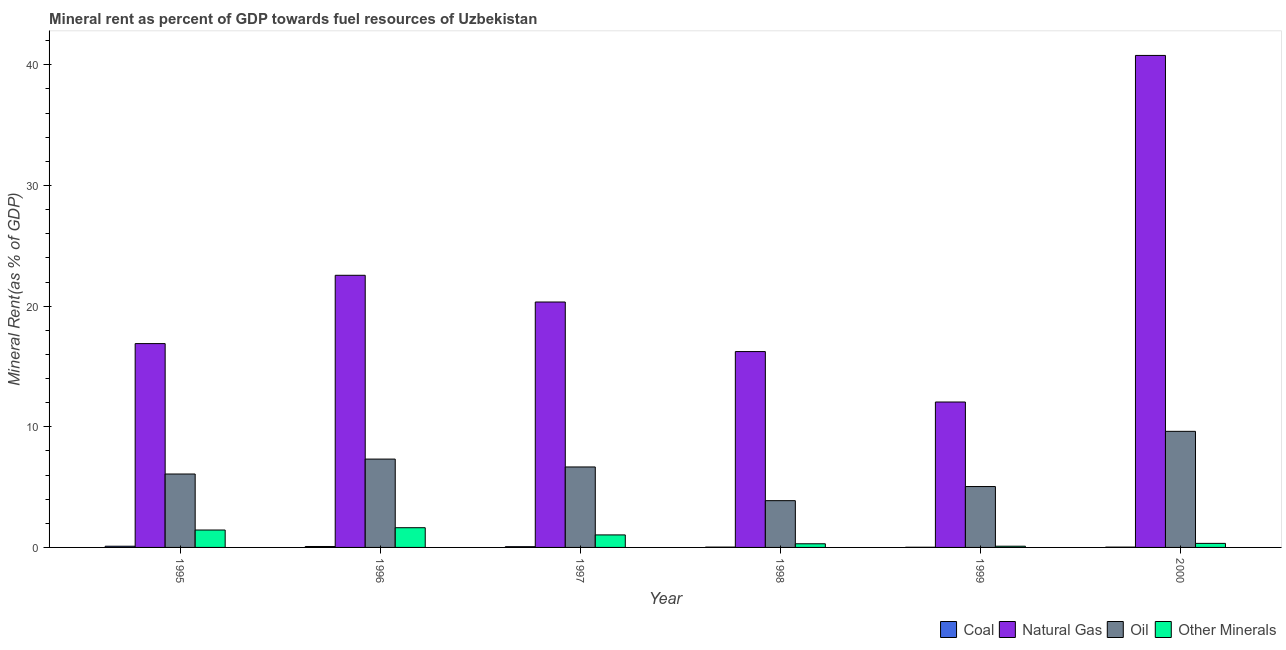How many groups of bars are there?
Offer a very short reply. 6. Are the number of bars per tick equal to the number of legend labels?
Ensure brevity in your answer.  Yes. Are the number of bars on each tick of the X-axis equal?
Your response must be concise. Yes. How many bars are there on the 6th tick from the right?
Provide a succinct answer. 4. What is the  rent of other minerals in 1999?
Provide a short and direct response. 0.1. Across all years, what is the maximum oil rent?
Provide a short and direct response. 9.62. Across all years, what is the minimum coal rent?
Provide a succinct answer. 0.01. What is the total  rent of other minerals in the graph?
Give a very brief answer. 4.85. What is the difference between the oil rent in 1999 and that in 2000?
Ensure brevity in your answer.  -4.58. What is the difference between the coal rent in 1995 and the natural gas rent in 1997?
Provide a succinct answer. 0.04. What is the average  rent of other minerals per year?
Provide a succinct answer. 0.81. In how many years, is the  rent of other minerals greater than 40 %?
Provide a short and direct response. 0. What is the ratio of the  rent of other minerals in 1996 to that in 1999?
Ensure brevity in your answer.  16.17. Is the oil rent in 1997 less than that in 1999?
Give a very brief answer. No. Is the difference between the  rent of other minerals in 1995 and 1996 greater than the difference between the coal rent in 1995 and 1996?
Your answer should be compact. No. What is the difference between the highest and the second highest coal rent?
Your response must be concise. 0.02. What is the difference between the highest and the lowest coal rent?
Ensure brevity in your answer.  0.09. In how many years, is the oil rent greater than the average oil rent taken over all years?
Provide a succinct answer. 3. Is it the case that in every year, the sum of the coal rent and natural gas rent is greater than the sum of  rent of other minerals and oil rent?
Give a very brief answer. No. What does the 2nd bar from the left in 1997 represents?
Make the answer very short. Natural Gas. What does the 4th bar from the right in 1995 represents?
Ensure brevity in your answer.  Coal. Is it the case that in every year, the sum of the coal rent and natural gas rent is greater than the oil rent?
Keep it short and to the point. Yes. How many bars are there?
Your answer should be very brief. 24. How many years are there in the graph?
Your answer should be compact. 6. Are the values on the major ticks of Y-axis written in scientific E-notation?
Your answer should be very brief. No. Does the graph contain any zero values?
Give a very brief answer. No. Does the graph contain grids?
Offer a very short reply. No. Where does the legend appear in the graph?
Provide a succinct answer. Bottom right. How are the legend labels stacked?
Make the answer very short. Horizontal. What is the title of the graph?
Your answer should be very brief. Mineral rent as percent of GDP towards fuel resources of Uzbekistan. What is the label or title of the X-axis?
Your answer should be very brief. Year. What is the label or title of the Y-axis?
Offer a terse response. Mineral Rent(as % of GDP). What is the Mineral Rent(as % of GDP) of Coal in 1995?
Provide a short and direct response. 0.1. What is the Mineral Rent(as % of GDP) of Natural Gas in 1995?
Your answer should be compact. 16.9. What is the Mineral Rent(as % of GDP) in Oil in 1995?
Offer a very short reply. 6.09. What is the Mineral Rent(as % of GDP) of Other Minerals in 1995?
Provide a short and direct response. 1.44. What is the Mineral Rent(as % of GDP) in Coal in 1996?
Keep it short and to the point. 0.08. What is the Mineral Rent(as % of GDP) of Natural Gas in 1996?
Your response must be concise. 22.56. What is the Mineral Rent(as % of GDP) in Oil in 1996?
Offer a very short reply. 7.32. What is the Mineral Rent(as % of GDP) in Other Minerals in 1996?
Provide a succinct answer. 1.63. What is the Mineral Rent(as % of GDP) of Coal in 1997?
Offer a very short reply. 0.06. What is the Mineral Rent(as % of GDP) in Natural Gas in 1997?
Your response must be concise. 20.34. What is the Mineral Rent(as % of GDP) of Oil in 1997?
Ensure brevity in your answer.  6.67. What is the Mineral Rent(as % of GDP) in Other Minerals in 1997?
Your answer should be compact. 1.04. What is the Mineral Rent(as % of GDP) of Coal in 1998?
Keep it short and to the point. 0.03. What is the Mineral Rent(as % of GDP) in Natural Gas in 1998?
Your answer should be compact. 16.23. What is the Mineral Rent(as % of GDP) of Oil in 1998?
Offer a very short reply. 3.88. What is the Mineral Rent(as % of GDP) in Other Minerals in 1998?
Your answer should be very brief. 0.3. What is the Mineral Rent(as % of GDP) in Coal in 1999?
Offer a terse response. 0.01. What is the Mineral Rent(as % of GDP) of Natural Gas in 1999?
Your response must be concise. 12.05. What is the Mineral Rent(as % of GDP) of Oil in 1999?
Offer a terse response. 5.05. What is the Mineral Rent(as % of GDP) in Other Minerals in 1999?
Your answer should be compact. 0.1. What is the Mineral Rent(as % of GDP) in Coal in 2000?
Keep it short and to the point. 0.03. What is the Mineral Rent(as % of GDP) of Natural Gas in 2000?
Keep it short and to the point. 40.78. What is the Mineral Rent(as % of GDP) in Oil in 2000?
Provide a short and direct response. 9.62. What is the Mineral Rent(as % of GDP) in Other Minerals in 2000?
Give a very brief answer. 0.34. Across all years, what is the maximum Mineral Rent(as % of GDP) in Coal?
Offer a very short reply. 0.1. Across all years, what is the maximum Mineral Rent(as % of GDP) in Natural Gas?
Provide a succinct answer. 40.78. Across all years, what is the maximum Mineral Rent(as % of GDP) in Oil?
Offer a terse response. 9.62. Across all years, what is the maximum Mineral Rent(as % of GDP) in Other Minerals?
Keep it short and to the point. 1.63. Across all years, what is the minimum Mineral Rent(as % of GDP) of Coal?
Offer a terse response. 0.01. Across all years, what is the minimum Mineral Rent(as % of GDP) in Natural Gas?
Give a very brief answer. 12.05. Across all years, what is the minimum Mineral Rent(as % of GDP) in Oil?
Make the answer very short. 3.88. Across all years, what is the minimum Mineral Rent(as % of GDP) of Other Minerals?
Offer a very short reply. 0.1. What is the total Mineral Rent(as % of GDP) of Coal in the graph?
Make the answer very short. 0.31. What is the total Mineral Rent(as % of GDP) of Natural Gas in the graph?
Offer a very short reply. 128.87. What is the total Mineral Rent(as % of GDP) of Oil in the graph?
Provide a succinct answer. 38.62. What is the total Mineral Rent(as % of GDP) in Other Minerals in the graph?
Make the answer very short. 4.85. What is the difference between the Mineral Rent(as % of GDP) in Coal in 1995 and that in 1996?
Make the answer very short. 0.02. What is the difference between the Mineral Rent(as % of GDP) in Natural Gas in 1995 and that in 1996?
Your answer should be very brief. -5.66. What is the difference between the Mineral Rent(as % of GDP) of Oil in 1995 and that in 1996?
Offer a terse response. -1.24. What is the difference between the Mineral Rent(as % of GDP) of Other Minerals in 1995 and that in 1996?
Your response must be concise. -0.19. What is the difference between the Mineral Rent(as % of GDP) in Coal in 1995 and that in 1997?
Keep it short and to the point. 0.04. What is the difference between the Mineral Rent(as % of GDP) in Natural Gas in 1995 and that in 1997?
Provide a succinct answer. -3.45. What is the difference between the Mineral Rent(as % of GDP) of Oil in 1995 and that in 1997?
Offer a terse response. -0.58. What is the difference between the Mineral Rent(as % of GDP) in Other Minerals in 1995 and that in 1997?
Offer a terse response. 0.4. What is the difference between the Mineral Rent(as % of GDP) of Coal in 1995 and that in 1998?
Ensure brevity in your answer.  0.07. What is the difference between the Mineral Rent(as % of GDP) of Natural Gas in 1995 and that in 1998?
Keep it short and to the point. 0.66. What is the difference between the Mineral Rent(as % of GDP) in Oil in 1995 and that in 1998?
Give a very brief answer. 2.21. What is the difference between the Mineral Rent(as % of GDP) of Other Minerals in 1995 and that in 1998?
Your answer should be compact. 1.14. What is the difference between the Mineral Rent(as % of GDP) in Coal in 1995 and that in 1999?
Ensure brevity in your answer.  0.09. What is the difference between the Mineral Rent(as % of GDP) of Natural Gas in 1995 and that in 1999?
Give a very brief answer. 4.84. What is the difference between the Mineral Rent(as % of GDP) in Oil in 1995 and that in 1999?
Give a very brief answer. 1.04. What is the difference between the Mineral Rent(as % of GDP) in Other Minerals in 1995 and that in 1999?
Provide a short and direct response. 1.34. What is the difference between the Mineral Rent(as % of GDP) of Coal in 1995 and that in 2000?
Give a very brief answer. 0.07. What is the difference between the Mineral Rent(as % of GDP) in Natural Gas in 1995 and that in 2000?
Your response must be concise. -23.89. What is the difference between the Mineral Rent(as % of GDP) in Oil in 1995 and that in 2000?
Your answer should be compact. -3.54. What is the difference between the Mineral Rent(as % of GDP) in Other Minerals in 1995 and that in 2000?
Make the answer very short. 1.11. What is the difference between the Mineral Rent(as % of GDP) in Coal in 1996 and that in 1997?
Offer a terse response. 0.02. What is the difference between the Mineral Rent(as % of GDP) in Natural Gas in 1996 and that in 1997?
Offer a very short reply. 2.21. What is the difference between the Mineral Rent(as % of GDP) of Oil in 1996 and that in 1997?
Provide a succinct answer. 0.65. What is the difference between the Mineral Rent(as % of GDP) of Other Minerals in 1996 and that in 1997?
Make the answer very short. 0.6. What is the difference between the Mineral Rent(as % of GDP) of Coal in 1996 and that in 1998?
Your answer should be compact. 0.05. What is the difference between the Mineral Rent(as % of GDP) of Natural Gas in 1996 and that in 1998?
Give a very brief answer. 6.32. What is the difference between the Mineral Rent(as % of GDP) of Oil in 1996 and that in 1998?
Offer a very short reply. 3.45. What is the difference between the Mineral Rent(as % of GDP) of Other Minerals in 1996 and that in 1998?
Offer a terse response. 1.33. What is the difference between the Mineral Rent(as % of GDP) in Coal in 1996 and that in 1999?
Your answer should be compact. 0.06. What is the difference between the Mineral Rent(as % of GDP) in Natural Gas in 1996 and that in 1999?
Give a very brief answer. 10.5. What is the difference between the Mineral Rent(as % of GDP) of Oil in 1996 and that in 1999?
Ensure brevity in your answer.  2.28. What is the difference between the Mineral Rent(as % of GDP) of Other Minerals in 1996 and that in 1999?
Give a very brief answer. 1.53. What is the difference between the Mineral Rent(as % of GDP) of Coal in 1996 and that in 2000?
Offer a very short reply. 0.05. What is the difference between the Mineral Rent(as % of GDP) of Natural Gas in 1996 and that in 2000?
Your answer should be compact. -18.23. What is the difference between the Mineral Rent(as % of GDP) of Oil in 1996 and that in 2000?
Your answer should be very brief. -2.3. What is the difference between the Mineral Rent(as % of GDP) of Other Minerals in 1996 and that in 2000?
Your answer should be compact. 1.3. What is the difference between the Mineral Rent(as % of GDP) of Coal in 1997 and that in 1998?
Ensure brevity in your answer.  0.04. What is the difference between the Mineral Rent(as % of GDP) in Natural Gas in 1997 and that in 1998?
Offer a very short reply. 4.11. What is the difference between the Mineral Rent(as % of GDP) of Oil in 1997 and that in 1998?
Provide a succinct answer. 2.79. What is the difference between the Mineral Rent(as % of GDP) of Other Minerals in 1997 and that in 1998?
Provide a succinct answer. 0.73. What is the difference between the Mineral Rent(as % of GDP) in Coal in 1997 and that in 1999?
Provide a short and direct response. 0.05. What is the difference between the Mineral Rent(as % of GDP) in Natural Gas in 1997 and that in 1999?
Offer a very short reply. 8.29. What is the difference between the Mineral Rent(as % of GDP) of Oil in 1997 and that in 1999?
Keep it short and to the point. 1.62. What is the difference between the Mineral Rent(as % of GDP) in Other Minerals in 1997 and that in 1999?
Your answer should be compact. 0.94. What is the difference between the Mineral Rent(as % of GDP) in Coal in 1997 and that in 2000?
Provide a short and direct response. 0.04. What is the difference between the Mineral Rent(as % of GDP) in Natural Gas in 1997 and that in 2000?
Ensure brevity in your answer.  -20.44. What is the difference between the Mineral Rent(as % of GDP) in Oil in 1997 and that in 2000?
Provide a succinct answer. -2.95. What is the difference between the Mineral Rent(as % of GDP) of Other Minerals in 1997 and that in 2000?
Offer a very short reply. 0.7. What is the difference between the Mineral Rent(as % of GDP) in Coal in 1998 and that in 1999?
Provide a short and direct response. 0.01. What is the difference between the Mineral Rent(as % of GDP) in Natural Gas in 1998 and that in 1999?
Your response must be concise. 4.18. What is the difference between the Mineral Rent(as % of GDP) in Oil in 1998 and that in 1999?
Give a very brief answer. -1.17. What is the difference between the Mineral Rent(as % of GDP) of Other Minerals in 1998 and that in 1999?
Your response must be concise. 0.2. What is the difference between the Mineral Rent(as % of GDP) in Coal in 1998 and that in 2000?
Your response must be concise. 0. What is the difference between the Mineral Rent(as % of GDP) of Natural Gas in 1998 and that in 2000?
Give a very brief answer. -24.55. What is the difference between the Mineral Rent(as % of GDP) of Oil in 1998 and that in 2000?
Offer a terse response. -5.75. What is the difference between the Mineral Rent(as % of GDP) of Other Minerals in 1998 and that in 2000?
Give a very brief answer. -0.03. What is the difference between the Mineral Rent(as % of GDP) in Coal in 1999 and that in 2000?
Your response must be concise. -0.01. What is the difference between the Mineral Rent(as % of GDP) of Natural Gas in 1999 and that in 2000?
Provide a short and direct response. -28.73. What is the difference between the Mineral Rent(as % of GDP) of Oil in 1999 and that in 2000?
Your answer should be compact. -4.58. What is the difference between the Mineral Rent(as % of GDP) of Other Minerals in 1999 and that in 2000?
Give a very brief answer. -0.23. What is the difference between the Mineral Rent(as % of GDP) of Coal in 1995 and the Mineral Rent(as % of GDP) of Natural Gas in 1996?
Your answer should be very brief. -22.46. What is the difference between the Mineral Rent(as % of GDP) in Coal in 1995 and the Mineral Rent(as % of GDP) in Oil in 1996?
Give a very brief answer. -7.22. What is the difference between the Mineral Rent(as % of GDP) in Coal in 1995 and the Mineral Rent(as % of GDP) in Other Minerals in 1996?
Keep it short and to the point. -1.53. What is the difference between the Mineral Rent(as % of GDP) in Natural Gas in 1995 and the Mineral Rent(as % of GDP) in Oil in 1996?
Your response must be concise. 9.57. What is the difference between the Mineral Rent(as % of GDP) of Natural Gas in 1995 and the Mineral Rent(as % of GDP) of Other Minerals in 1996?
Your answer should be compact. 15.26. What is the difference between the Mineral Rent(as % of GDP) of Oil in 1995 and the Mineral Rent(as % of GDP) of Other Minerals in 1996?
Keep it short and to the point. 4.45. What is the difference between the Mineral Rent(as % of GDP) in Coal in 1995 and the Mineral Rent(as % of GDP) in Natural Gas in 1997?
Provide a short and direct response. -20.24. What is the difference between the Mineral Rent(as % of GDP) in Coal in 1995 and the Mineral Rent(as % of GDP) in Oil in 1997?
Make the answer very short. -6.57. What is the difference between the Mineral Rent(as % of GDP) of Coal in 1995 and the Mineral Rent(as % of GDP) of Other Minerals in 1997?
Your answer should be very brief. -0.94. What is the difference between the Mineral Rent(as % of GDP) of Natural Gas in 1995 and the Mineral Rent(as % of GDP) of Oil in 1997?
Make the answer very short. 10.23. What is the difference between the Mineral Rent(as % of GDP) of Natural Gas in 1995 and the Mineral Rent(as % of GDP) of Other Minerals in 1997?
Provide a short and direct response. 15.86. What is the difference between the Mineral Rent(as % of GDP) in Oil in 1995 and the Mineral Rent(as % of GDP) in Other Minerals in 1997?
Provide a short and direct response. 5.05. What is the difference between the Mineral Rent(as % of GDP) of Coal in 1995 and the Mineral Rent(as % of GDP) of Natural Gas in 1998?
Ensure brevity in your answer.  -16.13. What is the difference between the Mineral Rent(as % of GDP) of Coal in 1995 and the Mineral Rent(as % of GDP) of Oil in 1998?
Provide a short and direct response. -3.78. What is the difference between the Mineral Rent(as % of GDP) in Coal in 1995 and the Mineral Rent(as % of GDP) in Other Minerals in 1998?
Provide a short and direct response. -0.2. What is the difference between the Mineral Rent(as % of GDP) of Natural Gas in 1995 and the Mineral Rent(as % of GDP) of Oil in 1998?
Your response must be concise. 13.02. What is the difference between the Mineral Rent(as % of GDP) of Natural Gas in 1995 and the Mineral Rent(as % of GDP) of Other Minerals in 1998?
Your answer should be very brief. 16.59. What is the difference between the Mineral Rent(as % of GDP) in Oil in 1995 and the Mineral Rent(as % of GDP) in Other Minerals in 1998?
Offer a terse response. 5.78. What is the difference between the Mineral Rent(as % of GDP) in Coal in 1995 and the Mineral Rent(as % of GDP) in Natural Gas in 1999?
Ensure brevity in your answer.  -11.95. What is the difference between the Mineral Rent(as % of GDP) in Coal in 1995 and the Mineral Rent(as % of GDP) in Oil in 1999?
Keep it short and to the point. -4.95. What is the difference between the Mineral Rent(as % of GDP) of Coal in 1995 and the Mineral Rent(as % of GDP) of Other Minerals in 1999?
Provide a succinct answer. -0. What is the difference between the Mineral Rent(as % of GDP) of Natural Gas in 1995 and the Mineral Rent(as % of GDP) of Oil in 1999?
Give a very brief answer. 11.85. What is the difference between the Mineral Rent(as % of GDP) in Natural Gas in 1995 and the Mineral Rent(as % of GDP) in Other Minerals in 1999?
Your answer should be compact. 16.79. What is the difference between the Mineral Rent(as % of GDP) in Oil in 1995 and the Mineral Rent(as % of GDP) in Other Minerals in 1999?
Give a very brief answer. 5.98. What is the difference between the Mineral Rent(as % of GDP) in Coal in 1995 and the Mineral Rent(as % of GDP) in Natural Gas in 2000?
Offer a terse response. -40.68. What is the difference between the Mineral Rent(as % of GDP) in Coal in 1995 and the Mineral Rent(as % of GDP) in Oil in 2000?
Your response must be concise. -9.52. What is the difference between the Mineral Rent(as % of GDP) in Coal in 1995 and the Mineral Rent(as % of GDP) in Other Minerals in 2000?
Give a very brief answer. -0.24. What is the difference between the Mineral Rent(as % of GDP) in Natural Gas in 1995 and the Mineral Rent(as % of GDP) in Oil in 2000?
Your answer should be very brief. 7.27. What is the difference between the Mineral Rent(as % of GDP) of Natural Gas in 1995 and the Mineral Rent(as % of GDP) of Other Minerals in 2000?
Offer a very short reply. 16.56. What is the difference between the Mineral Rent(as % of GDP) in Oil in 1995 and the Mineral Rent(as % of GDP) in Other Minerals in 2000?
Offer a very short reply. 5.75. What is the difference between the Mineral Rent(as % of GDP) in Coal in 1996 and the Mineral Rent(as % of GDP) in Natural Gas in 1997?
Your answer should be compact. -20.27. What is the difference between the Mineral Rent(as % of GDP) in Coal in 1996 and the Mineral Rent(as % of GDP) in Oil in 1997?
Give a very brief answer. -6.59. What is the difference between the Mineral Rent(as % of GDP) of Coal in 1996 and the Mineral Rent(as % of GDP) of Other Minerals in 1997?
Provide a succinct answer. -0.96. What is the difference between the Mineral Rent(as % of GDP) of Natural Gas in 1996 and the Mineral Rent(as % of GDP) of Oil in 1997?
Keep it short and to the point. 15.89. What is the difference between the Mineral Rent(as % of GDP) of Natural Gas in 1996 and the Mineral Rent(as % of GDP) of Other Minerals in 1997?
Provide a succinct answer. 21.52. What is the difference between the Mineral Rent(as % of GDP) in Oil in 1996 and the Mineral Rent(as % of GDP) in Other Minerals in 1997?
Provide a short and direct response. 6.29. What is the difference between the Mineral Rent(as % of GDP) in Coal in 1996 and the Mineral Rent(as % of GDP) in Natural Gas in 1998?
Provide a succinct answer. -16.16. What is the difference between the Mineral Rent(as % of GDP) in Coal in 1996 and the Mineral Rent(as % of GDP) in Oil in 1998?
Provide a short and direct response. -3.8. What is the difference between the Mineral Rent(as % of GDP) in Coal in 1996 and the Mineral Rent(as % of GDP) in Other Minerals in 1998?
Make the answer very short. -0.23. What is the difference between the Mineral Rent(as % of GDP) of Natural Gas in 1996 and the Mineral Rent(as % of GDP) of Oil in 1998?
Provide a succinct answer. 18.68. What is the difference between the Mineral Rent(as % of GDP) in Natural Gas in 1996 and the Mineral Rent(as % of GDP) in Other Minerals in 1998?
Your response must be concise. 22.25. What is the difference between the Mineral Rent(as % of GDP) in Oil in 1996 and the Mineral Rent(as % of GDP) in Other Minerals in 1998?
Your answer should be very brief. 7.02. What is the difference between the Mineral Rent(as % of GDP) of Coal in 1996 and the Mineral Rent(as % of GDP) of Natural Gas in 1999?
Offer a terse response. -11.98. What is the difference between the Mineral Rent(as % of GDP) in Coal in 1996 and the Mineral Rent(as % of GDP) in Oil in 1999?
Keep it short and to the point. -4.97. What is the difference between the Mineral Rent(as % of GDP) of Coal in 1996 and the Mineral Rent(as % of GDP) of Other Minerals in 1999?
Your response must be concise. -0.02. What is the difference between the Mineral Rent(as % of GDP) of Natural Gas in 1996 and the Mineral Rent(as % of GDP) of Oil in 1999?
Your answer should be compact. 17.51. What is the difference between the Mineral Rent(as % of GDP) in Natural Gas in 1996 and the Mineral Rent(as % of GDP) in Other Minerals in 1999?
Make the answer very short. 22.46. What is the difference between the Mineral Rent(as % of GDP) of Oil in 1996 and the Mineral Rent(as % of GDP) of Other Minerals in 1999?
Ensure brevity in your answer.  7.22. What is the difference between the Mineral Rent(as % of GDP) in Coal in 1996 and the Mineral Rent(as % of GDP) in Natural Gas in 2000?
Keep it short and to the point. -40.7. What is the difference between the Mineral Rent(as % of GDP) in Coal in 1996 and the Mineral Rent(as % of GDP) in Oil in 2000?
Make the answer very short. -9.54. What is the difference between the Mineral Rent(as % of GDP) of Coal in 1996 and the Mineral Rent(as % of GDP) of Other Minerals in 2000?
Keep it short and to the point. -0.26. What is the difference between the Mineral Rent(as % of GDP) in Natural Gas in 1996 and the Mineral Rent(as % of GDP) in Oil in 2000?
Give a very brief answer. 12.93. What is the difference between the Mineral Rent(as % of GDP) in Natural Gas in 1996 and the Mineral Rent(as % of GDP) in Other Minerals in 2000?
Your answer should be compact. 22.22. What is the difference between the Mineral Rent(as % of GDP) in Oil in 1996 and the Mineral Rent(as % of GDP) in Other Minerals in 2000?
Offer a terse response. 6.99. What is the difference between the Mineral Rent(as % of GDP) in Coal in 1997 and the Mineral Rent(as % of GDP) in Natural Gas in 1998?
Offer a terse response. -16.17. What is the difference between the Mineral Rent(as % of GDP) of Coal in 1997 and the Mineral Rent(as % of GDP) of Oil in 1998?
Offer a very short reply. -3.81. What is the difference between the Mineral Rent(as % of GDP) in Coal in 1997 and the Mineral Rent(as % of GDP) in Other Minerals in 1998?
Make the answer very short. -0.24. What is the difference between the Mineral Rent(as % of GDP) in Natural Gas in 1997 and the Mineral Rent(as % of GDP) in Oil in 1998?
Offer a very short reply. 16.47. What is the difference between the Mineral Rent(as % of GDP) of Natural Gas in 1997 and the Mineral Rent(as % of GDP) of Other Minerals in 1998?
Provide a succinct answer. 20.04. What is the difference between the Mineral Rent(as % of GDP) of Oil in 1997 and the Mineral Rent(as % of GDP) of Other Minerals in 1998?
Your answer should be compact. 6.37. What is the difference between the Mineral Rent(as % of GDP) of Coal in 1997 and the Mineral Rent(as % of GDP) of Natural Gas in 1999?
Make the answer very short. -11.99. What is the difference between the Mineral Rent(as % of GDP) in Coal in 1997 and the Mineral Rent(as % of GDP) in Oil in 1999?
Offer a very short reply. -4.98. What is the difference between the Mineral Rent(as % of GDP) in Coal in 1997 and the Mineral Rent(as % of GDP) in Other Minerals in 1999?
Offer a terse response. -0.04. What is the difference between the Mineral Rent(as % of GDP) of Natural Gas in 1997 and the Mineral Rent(as % of GDP) of Oil in 1999?
Your answer should be compact. 15.3. What is the difference between the Mineral Rent(as % of GDP) in Natural Gas in 1997 and the Mineral Rent(as % of GDP) in Other Minerals in 1999?
Provide a succinct answer. 20.24. What is the difference between the Mineral Rent(as % of GDP) of Oil in 1997 and the Mineral Rent(as % of GDP) of Other Minerals in 1999?
Your response must be concise. 6.57. What is the difference between the Mineral Rent(as % of GDP) of Coal in 1997 and the Mineral Rent(as % of GDP) of Natural Gas in 2000?
Your answer should be very brief. -40.72. What is the difference between the Mineral Rent(as % of GDP) in Coal in 1997 and the Mineral Rent(as % of GDP) in Oil in 2000?
Ensure brevity in your answer.  -9.56. What is the difference between the Mineral Rent(as % of GDP) of Coal in 1997 and the Mineral Rent(as % of GDP) of Other Minerals in 2000?
Ensure brevity in your answer.  -0.27. What is the difference between the Mineral Rent(as % of GDP) of Natural Gas in 1997 and the Mineral Rent(as % of GDP) of Oil in 2000?
Your response must be concise. 10.72. What is the difference between the Mineral Rent(as % of GDP) in Natural Gas in 1997 and the Mineral Rent(as % of GDP) in Other Minerals in 2000?
Your answer should be compact. 20.01. What is the difference between the Mineral Rent(as % of GDP) in Oil in 1997 and the Mineral Rent(as % of GDP) in Other Minerals in 2000?
Give a very brief answer. 6.33. What is the difference between the Mineral Rent(as % of GDP) of Coal in 1998 and the Mineral Rent(as % of GDP) of Natural Gas in 1999?
Make the answer very short. -12.03. What is the difference between the Mineral Rent(as % of GDP) of Coal in 1998 and the Mineral Rent(as % of GDP) of Oil in 1999?
Your response must be concise. -5.02. What is the difference between the Mineral Rent(as % of GDP) of Coal in 1998 and the Mineral Rent(as % of GDP) of Other Minerals in 1999?
Your answer should be very brief. -0.07. What is the difference between the Mineral Rent(as % of GDP) of Natural Gas in 1998 and the Mineral Rent(as % of GDP) of Oil in 1999?
Provide a short and direct response. 11.19. What is the difference between the Mineral Rent(as % of GDP) in Natural Gas in 1998 and the Mineral Rent(as % of GDP) in Other Minerals in 1999?
Give a very brief answer. 16.13. What is the difference between the Mineral Rent(as % of GDP) of Oil in 1998 and the Mineral Rent(as % of GDP) of Other Minerals in 1999?
Provide a short and direct response. 3.78. What is the difference between the Mineral Rent(as % of GDP) in Coal in 1998 and the Mineral Rent(as % of GDP) in Natural Gas in 2000?
Provide a short and direct response. -40.76. What is the difference between the Mineral Rent(as % of GDP) in Coal in 1998 and the Mineral Rent(as % of GDP) in Oil in 2000?
Your answer should be very brief. -9.6. What is the difference between the Mineral Rent(as % of GDP) in Coal in 1998 and the Mineral Rent(as % of GDP) in Other Minerals in 2000?
Provide a short and direct response. -0.31. What is the difference between the Mineral Rent(as % of GDP) of Natural Gas in 1998 and the Mineral Rent(as % of GDP) of Oil in 2000?
Offer a very short reply. 6.61. What is the difference between the Mineral Rent(as % of GDP) in Natural Gas in 1998 and the Mineral Rent(as % of GDP) in Other Minerals in 2000?
Provide a short and direct response. 15.9. What is the difference between the Mineral Rent(as % of GDP) in Oil in 1998 and the Mineral Rent(as % of GDP) in Other Minerals in 2000?
Offer a terse response. 3.54. What is the difference between the Mineral Rent(as % of GDP) of Coal in 1999 and the Mineral Rent(as % of GDP) of Natural Gas in 2000?
Provide a short and direct response. -40.77. What is the difference between the Mineral Rent(as % of GDP) of Coal in 1999 and the Mineral Rent(as % of GDP) of Oil in 2000?
Give a very brief answer. -9.61. What is the difference between the Mineral Rent(as % of GDP) of Coal in 1999 and the Mineral Rent(as % of GDP) of Other Minerals in 2000?
Offer a very short reply. -0.32. What is the difference between the Mineral Rent(as % of GDP) in Natural Gas in 1999 and the Mineral Rent(as % of GDP) in Oil in 2000?
Ensure brevity in your answer.  2.43. What is the difference between the Mineral Rent(as % of GDP) of Natural Gas in 1999 and the Mineral Rent(as % of GDP) of Other Minerals in 2000?
Provide a succinct answer. 11.72. What is the difference between the Mineral Rent(as % of GDP) of Oil in 1999 and the Mineral Rent(as % of GDP) of Other Minerals in 2000?
Your answer should be very brief. 4.71. What is the average Mineral Rent(as % of GDP) in Coal per year?
Your response must be concise. 0.05. What is the average Mineral Rent(as % of GDP) of Natural Gas per year?
Make the answer very short. 21.48. What is the average Mineral Rent(as % of GDP) in Oil per year?
Make the answer very short. 6.44. What is the average Mineral Rent(as % of GDP) in Other Minerals per year?
Give a very brief answer. 0.81. In the year 1995, what is the difference between the Mineral Rent(as % of GDP) of Coal and Mineral Rent(as % of GDP) of Natural Gas?
Offer a terse response. -16.8. In the year 1995, what is the difference between the Mineral Rent(as % of GDP) of Coal and Mineral Rent(as % of GDP) of Oil?
Your response must be concise. -5.99. In the year 1995, what is the difference between the Mineral Rent(as % of GDP) in Coal and Mineral Rent(as % of GDP) in Other Minerals?
Provide a succinct answer. -1.34. In the year 1995, what is the difference between the Mineral Rent(as % of GDP) in Natural Gas and Mineral Rent(as % of GDP) in Oil?
Ensure brevity in your answer.  10.81. In the year 1995, what is the difference between the Mineral Rent(as % of GDP) of Natural Gas and Mineral Rent(as % of GDP) of Other Minerals?
Provide a short and direct response. 15.45. In the year 1995, what is the difference between the Mineral Rent(as % of GDP) of Oil and Mineral Rent(as % of GDP) of Other Minerals?
Ensure brevity in your answer.  4.64. In the year 1996, what is the difference between the Mineral Rent(as % of GDP) in Coal and Mineral Rent(as % of GDP) in Natural Gas?
Offer a terse response. -22.48. In the year 1996, what is the difference between the Mineral Rent(as % of GDP) in Coal and Mineral Rent(as % of GDP) in Oil?
Offer a terse response. -7.24. In the year 1996, what is the difference between the Mineral Rent(as % of GDP) in Coal and Mineral Rent(as % of GDP) in Other Minerals?
Your response must be concise. -1.56. In the year 1996, what is the difference between the Mineral Rent(as % of GDP) in Natural Gas and Mineral Rent(as % of GDP) in Oil?
Your answer should be compact. 15.23. In the year 1996, what is the difference between the Mineral Rent(as % of GDP) in Natural Gas and Mineral Rent(as % of GDP) in Other Minerals?
Offer a terse response. 20.92. In the year 1996, what is the difference between the Mineral Rent(as % of GDP) in Oil and Mineral Rent(as % of GDP) in Other Minerals?
Offer a very short reply. 5.69. In the year 1997, what is the difference between the Mineral Rent(as % of GDP) in Coal and Mineral Rent(as % of GDP) in Natural Gas?
Make the answer very short. -20.28. In the year 1997, what is the difference between the Mineral Rent(as % of GDP) in Coal and Mineral Rent(as % of GDP) in Oil?
Your answer should be compact. -6.61. In the year 1997, what is the difference between the Mineral Rent(as % of GDP) of Coal and Mineral Rent(as % of GDP) of Other Minerals?
Give a very brief answer. -0.97. In the year 1997, what is the difference between the Mineral Rent(as % of GDP) in Natural Gas and Mineral Rent(as % of GDP) in Oil?
Offer a terse response. 13.67. In the year 1997, what is the difference between the Mineral Rent(as % of GDP) in Natural Gas and Mineral Rent(as % of GDP) in Other Minerals?
Ensure brevity in your answer.  19.31. In the year 1997, what is the difference between the Mineral Rent(as % of GDP) of Oil and Mineral Rent(as % of GDP) of Other Minerals?
Your answer should be compact. 5.63. In the year 1998, what is the difference between the Mineral Rent(as % of GDP) in Coal and Mineral Rent(as % of GDP) in Natural Gas?
Your response must be concise. -16.21. In the year 1998, what is the difference between the Mineral Rent(as % of GDP) in Coal and Mineral Rent(as % of GDP) in Oil?
Your answer should be compact. -3.85. In the year 1998, what is the difference between the Mineral Rent(as % of GDP) of Coal and Mineral Rent(as % of GDP) of Other Minerals?
Ensure brevity in your answer.  -0.28. In the year 1998, what is the difference between the Mineral Rent(as % of GDP) in Natural Gas and Mineral Rent(as % of GDP) in Oil?
Provide a succinct answer. 12.36. In the year 1998, what is the difference between the Mineral Rent(as % of GDP) of Natural Gas and Mineral Rent(as % of GDP) of Other Minerals?
Offer a terse response. 15.93. In the year 1998, what is the difference between the Mineral Rent(as % of GDP) of Oil and Mineral Rent(as % of GDP) of Other Minerals?
Your answer should be very brief. 3.57. In the year 1999, what is the difference between the Mineral Rent(as % of GDP) of Coal and Mineral Rent(as % of GDP) of Natural Gas?
Offer a terse response. -12.04. In the year 1999, what is the difference between the Mineral Rent(as % of GDP) of Coal and Mineral Rent(as % of GDP) of Oil?
Your answer should be compact. -5.03. In the year 1999, what is the difference between the Mineral Rent(as % of GDP) in Coal and Mineral Rent(as % of GDP) in Other Minerals?
Offer a terse response. -0.09. In the year 1999, what is the difference between the Mineral Rent(as % of GDP) in Natural Gas and Mineral Rent(as % of GDP) in Oil?
Your response must be concise. 7.01. In the year 1999, what is the difference between the Mineral Rent(as % of GDP) in Natural Gas and Mineral Rent(as % of GDP) in Other Minerals?
Your answer should be compact. 11.95. In the year 1999, what is the difference between the Mineral Rent(as % of GDP) of Oil and Mineral Rent(as % of GDP) of Other Minerals?
Keep it short and to the point. 4.95. In the year 2000, what is the difference between the Mineral Rent(as % of GDP) in Coal and Mineral Rent(as % of GDP) in Natural Gas?
Your response must be concise. -40.76. In the year 2000, what is the difference between the Mineral Rent(as % of GDP) in Coal and Mineral Rent(as % of GDP) in Oil?
Offer a terse response. -9.6. In the year 2000, what is the difference between the Mineral Rent(as % of GDP) in Coal and Mineral Rent(as % of GDP) in Other Minerals?
Your answer should be compact. -0.31. In the year 2000, what is the difference between the Mineral Rent(as % of GDP) in Natural Gas and Mineral Rent(as % of GDP) in Oil?
Make the answer very short. 31.16. In the year 2000, what is the difference between the Mineral Rent(as % of GDP) in Natural Gas and Mineral Rent(as % of GDP) in Other Minerals?
Keep it short and to the point. 40.45. In the year 2000, what is the difference between the Mineral Rent(as % of GDP) in Oil and Mineral Rent(as % of GDP) in Other Minerals?
Provide a succinct answer. 9.29. What is the ratio of the Mineral Rent(as % of GDP) in Coal in 1995 to that in 1996?
Make the answer very short. 1.29. What is the ratio of the Mineral Rent(as % of GDP) in Natural Gas in 1995 to that in 1996?
Provide a succinct answer. 0.75. What is the ratio of the Mineral Rent(as % of GDP) of Oil in 1995 to that in 1996?
Your response must be concise. 0.83. What is the ratio of the Mineral Rent(as % of GDP) of Other Minerals in 1995 to that in 1996?
Offer a terse response. 0.88. What is the ratio of the Mineral Rent(as % of GDP) of Coal in 1995 to that in 1997?
Give a very brief answer. 1.6. What is the ratio of the Mineral Rent(as % of GDP) of Natural Gas in 1995 to that in 1997?
Offer a very short reply. 0.83. What is the ratio of the Mineral Rent(as % of GDP) in Oil in 1995 to that in 1997?
Ensure brevity in your answer.  0.91. What is the ratio of the Mineral Rent(as % of GDP) in Other Minerals in 1995 to that in 1997?
Give a very brief answer. 1.39. What is the ratio of the Mineral Rent(as % of GDP) of Coal in 1995 to that in 1998?
Your answer should be compact. 3.74. What is the ratio of the Mineral Rent(as % of GDP) in Natural Gas in 1995 to that in 1998?
Your answer should be very brief. 1.04. What is the ratio of the Mineral Rent(as % of GDP) in Oil in 1995 to that in 1998?
Make the answer very short. 1.57. What is the ratio of the Mineral Rent(as % of GDP) in Other Minerals in 1995 to that in 1998?
Ensure brevity in your answer.  4.75. What is the ratio of the Mineral Rent(as % of GDP) in Coal in 1995 to that in 1999?
Ensure brevity in your answer.  7.16. What is the ratio of the Mineral Rent(as % of GDP) in Natural Gas in 1995 to that in 1999?
Provide a short and direct response. 1.4. What is the ratio of the Mineral Rent(as % of GDP) of Oil in 1995 to that in 1999?
Offer a terse response. 1.21. What is the ratio of the Mineral Rent(as % of GDP) in Other Minerals in 1995 to that in 1999?
Provide a short and direct response. 14.27. What is the ratio of the Mineral Rent(as % of GDP) in Coal in 1995 to that in 2000?
Provide a short and direct response. 3.95. What is the ratio of the Mineral Rent(as % of GDP) in Natural Gas in 1995 to that in 2000?
Your response must be concise. 0.41. What is the ratio of the Mineral Rent(as % of GDP) in Oil in 1995 to that in 2000?
Your answer should be very brief. 0.63. What is the ratio of the Mineral Rent(as % of GDP) of Other Minerals in 1995 to that in 2000?
Keep it short and to the point. 4.3. What is the ratio of the Mineral Rent(as % of GDP) in Coal in 1996 to that in 1997?
Make the answer very short. 1.25. What is the ratio of the Mineral Rent(as % of GDP) in Natural Gas in 1996 to that in 1997?
Your answer should be compact. 1.11. What is the ratio of the Mineral Rent(as % of GDP) in Oil in 1996 to that in 1997?
Offer a terse response. 1.1. What is the ratio of the Mineral Rent(as % of GDP) of Other Minerals in 1996 to that in 1997?
Keep it short and to the point. 1.58. What is the ratio of the Mineral Rent(as % of GDP) of Coal in 1996 to that in 1998?
Provide a succinct answer. 2.91. What is the ratio of the Mineral Rent(as % of GDP) of Natural Gas in 1996 to that in 1998?
Offer a terse response. 1.39. What is the ratio of the Mineral Rent(as % of GDP) in Oil in 1996 to that in 1998?
Your answer should be compact. 1.89. What is the ratio of the Mineral Rent(as % of GDP) of Other Minerals in 1996 to that in 1998?
Make the answer very short. 5.39. What is the ratio of the Mineral Rent(as % of GDP) of Coal in 1996 to that in 1999?
Your response must be concise. 5.57. What is the ratio of the Mineral Rent(as % of GDP) of Natural Gas in 1996 to that in 1999?
Give a very brief answer. 1.87. What is the ratio of the Mineral Rent(as % of GDP) in Oil in 1996 to that in 1999?
Offer a very short reply. 1.45. What is the ratio of the Mineral Rent(as % of GDP) of Other Minerals in 1996 to that in 1999?
Give a very brief answer. 16.17. What is the ratio of the Mineral Rent(as % of GDP) of Coal in 1996 to that in 2000?
Ensure brevity in your answer.  3.07. What is the ratio of the Mineral Rent(as % of GDP) of Natural Gas in 1996 to that in 2000?
Make the answer very short. 0.55. What is the ratio of the Mineral Rent(as % of GDP) in Oil in 1996 to that in 2000?
Your answer should be compact. 0.76. What is the ratio of the Mineral Rent(as % of GDP) in Other Minerals in 1996 to that in 2000?
Provide a succinct answer. 4.88. What is the ratio of the Mineral Rent(as % of GDP) in Coal in 1997 to that in 1998?
Provide a short and direct response. 2.33. What is the ratio of the Mineral Rent(as % of GDP) of Natural Gas in 1997 to that in 1998?
Your answer should be compact. 1.25. What is the ratio of the Mineral Rent(as % of GDP) of Oil in 1997 to that in 1998?
Provide a short and direct response. 1.72. What is the ratio of the Mineral Rent(as % of GDP) of Other Minerals in 1997 to that in 1998?
Make the answer very short. 3.42. What is the ratio of the Mineral Rent(as % of GDP) in Coal in 1997 to that in 1999?
Offer a very short reply. 4.47. What is the ratio of the Mineral Rent(as % of GDP) in Natural Gas in 1997 to that in 1999?
Keep it short and to the point. 1.69. What is the ratio of the Mineral Rent(as % of GDP) of Oil in 1997 to that in 1999?
Keep it short and to the point. 1.32. What is the ratio of the Mineral Rent(as % of GDP) of Other Minerals in 1997 to that in 1999?
Give a very brief answer. 10.26. What is the ratio of the Mineral Rent(as % of GDP) in Coal in 1997 to that in 2000?
Your answer should be very brief. 2.46. What is the ratio of the Mineral Rent(as % of GDP) of Natural Gas in 1997 to that in 2000?
Provide a short and direct response. 0.5. What is the ratio of the Mineral Rent(as % of GDP) in Oil in 1997 to that in 2000?
Provide a short and direct response. 0.69. What is the ratio of the Mineral Rent(as % of GDP) of Other Minerals in 1997 to that in 2000?
Give a very brief answer. 3.09. What is the ratio of the Mineral Rent(as % of GDP) of Coal in 1998 to that in 1999?
Your answer should be very brief. 1.92. What is the ratio of the Mineral Rent(as % of GDP) in Natural Gas in 1998 to that in 1999?
Make the answer very short. 1.35. What is the ratio of the Mineral Rent(as % of GDP) in Oil in 1998 to that in 1999?
Your response must be concise. 0.77. What is the ratio of the Mineral Rent(as % of GDP) of Other Minerals in 1998 to that in 1999?
Your answer should be compact. 3. What is the ratio of the Mineral Rent(as % of GDP) in Coal in 1998 to that in 2000?
Offer a very short reply. 1.05. What is the ratio of the Mineral Rent(as % of GDP) in Natural Gas in 1998 to that in 2000?
Your answer should be very brief. 0.4. What is the ratio of the Mineral Rent(as % of GDP) in Oil in 1998 to that in 2000?
Your response must be concise. 0.4. What is the ratio of the Mineral Rent(as % of GDP) in Other Minerals in 1998 to that in 2000?
Offer a terse response. 0.91. What is the ratio of the Mineral Rent(as % of GDP) of Coal in 1999 to that in 2000?
Offer a very short reply. 0.55. What is the ratio of the Mineral Rent(as % of GDP) in Natural Gas in 1999 to that in 2000?
Your answer should be very brief. 0.3. What is the ratio of the Mineral Rent(as % of GDP) in Oil in 1999 to that in 2000?
Keep it short and to the point. 0.52. What is the ratio of the Mineral Rent(as % of GDP) of Other Minerals in 1999 to that in 2000?
Your answer should be compact. 0.3. What is the difference between the highest and the second highest Mineral Rent(as % of GDP) in Coal?
Your answer should be compact. 0.02. What is the difference between the highest and the second highest Mineral Rent(as % of GDP) of Natural Gas?
Your response must be concise. 18.23. What is the difference between the highest and the second highest Mineral Rent(as % of GDP) in Oil?
Your answer should be very brief. 2.3. What is the difference between the highest and the second highest Mineral Rent(as % of GDP) of Other Minerals?
Make the answer very short. 0.19. What is the difference between the highest and the lowest Mineral Rent(as % of GDP) of Coal?
Offer a terse response. 0.09. What is the difference between the highest and the lowest Mineral Rent(as % of GDP) in Natural Gas?
Offer a terse response. 28.73. What is the difference between the highest and the lowest Mineral Rent(as % of GDP) in Oil?
Provide a succinct answer. 5.75. What is the difference between the highest and the lowest Mineral Rent(as % of GDP) of Other Minerals?
Your answer should be very brief. 1.53. 